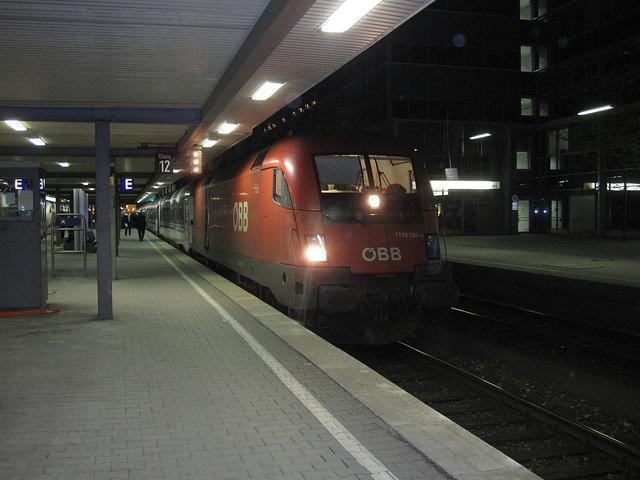What letter appears twice in a row on the train?
From the following four choices, select the correct answer to address the question.
Options: G, d, w, b. B. 